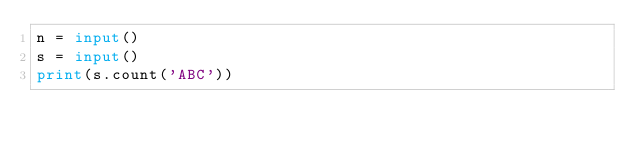Convert code to text. <code><loc_0><loc_0><loc_500><loc_500><_Python_>n = input()
s = input()
print(s.count('ABC'))</code> 